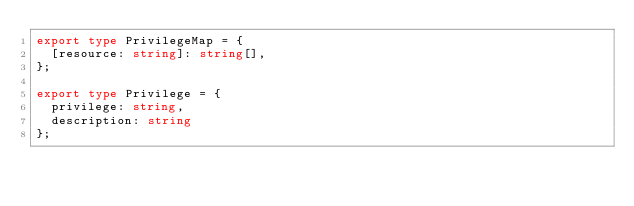<code> <loc_0><loc_0><loc_500><loc_500><_TypeScript_>export type PrivilegeMap = {
  [resource: string]: string[],
};

export type Privilege = {
  privilege: string,
  description: string
};
</code> 